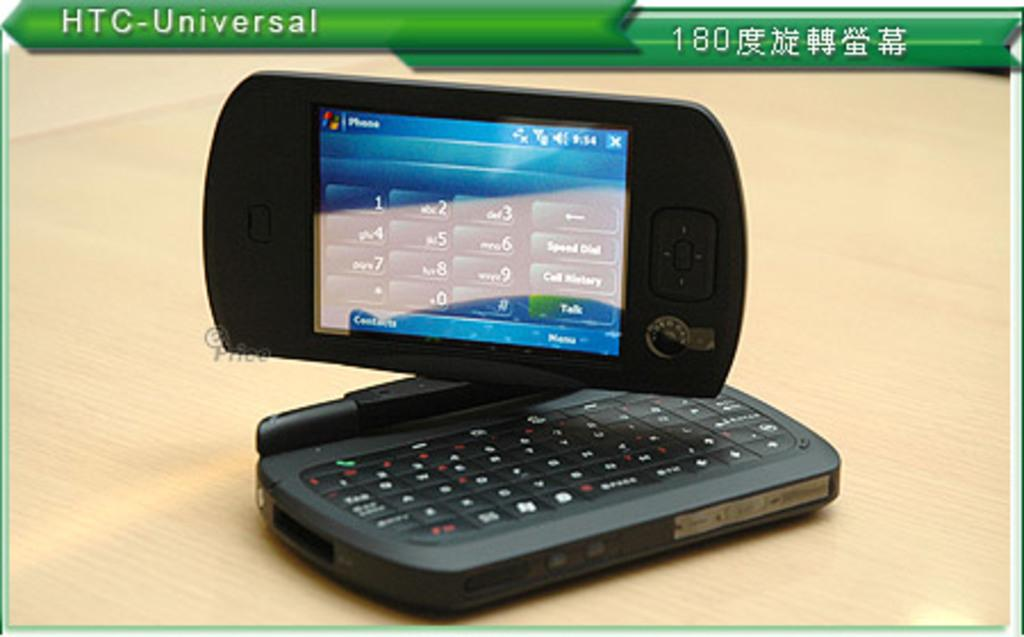<image>
Offer a succinct explanation of the picture presented. An advertisement displaying a HTC-Universal phone keypad on the screen. 